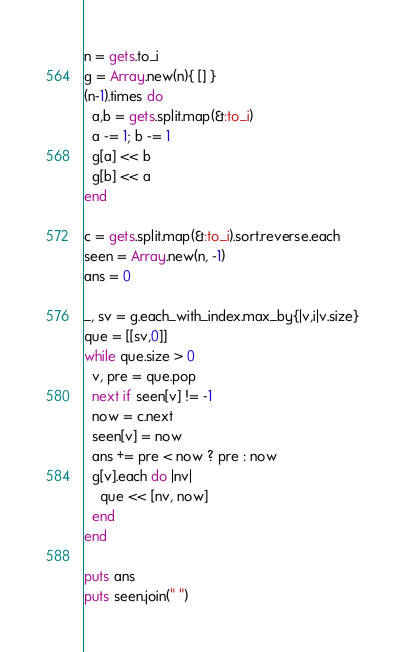Convert code to text. <code><loc_0><loc_0><loc_500><loc_500><_Ruby_>n = gets.to_i
g = Array.new(n){ [] }
(n-1).times do
  a,b = gets.split.map(&:to_i)
  a -= 1; b -= 1
  g[a] << b
  g[b] << a
end

c = gets.split.map(&:to_i).sort.reverse.each
seen = Array.new(n, -1)
ans = 0

_, sv = g.each_with_index.max_by{|v,i|v.size}
que = [[sv,0]]
while que.size > 0
  v, pre = que.pop
  next if seen[v] != -1
  now = c.next
  seen[v] = now
  ans += pre < now ? pre : now
  g[v].each do |nv|
    que << [nv, now]
  end
end

puts ans
puts seen.join(" ")
</code> 